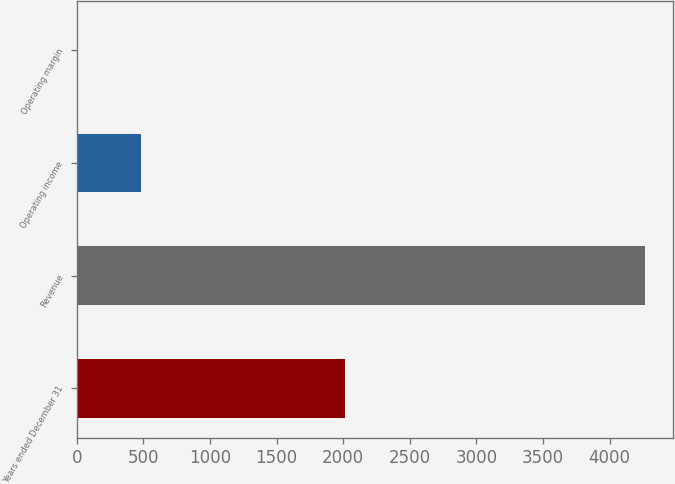Convert chart to OTSL. <chart><loc_0><loc_0><loc_500><loc_500><bar_chart><fcel>Years ended December 31<fcel>Revenue<fcel>Operating income<fcel>Operating margin<nl><fcel>2014<fcel>4264<fcel>485<fcel>11.4<nl></chart> 